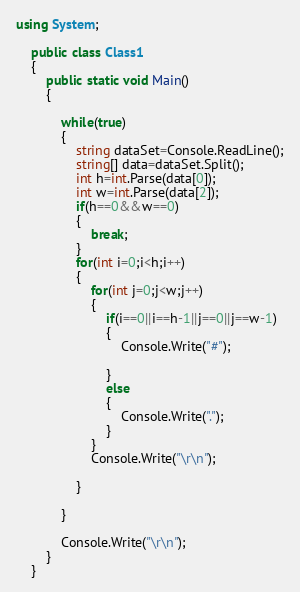Convert code to text. <code><loc_0><loc_0><loc_500><loc_500><_C#_>using System;

	public class Class1
	{
		public static void Main()
		{   
		
			while(true)
			{
				string dataSet=Console.ReadLine();
				string[] data=dataSet.Split();
				int h=int.Parse(data[0]);
				int w=int.Parse(data[2]);
				if(h==0&&w==0)
				{
					break;
				}
				for(int i=0;i<h;i++)
				{
					for(int j=0;j<w;j++)
					{
						if(i==0||i==h-1||j==0||j==w-1)
						{
							Console.Write("#");
							
						}
						else
						{
							Console.Write(".");
						}
					}
					Console.Write("\r\n");
						
				}
				
			}
				
			Console.Write("\r\n");
		}
	}</code> 